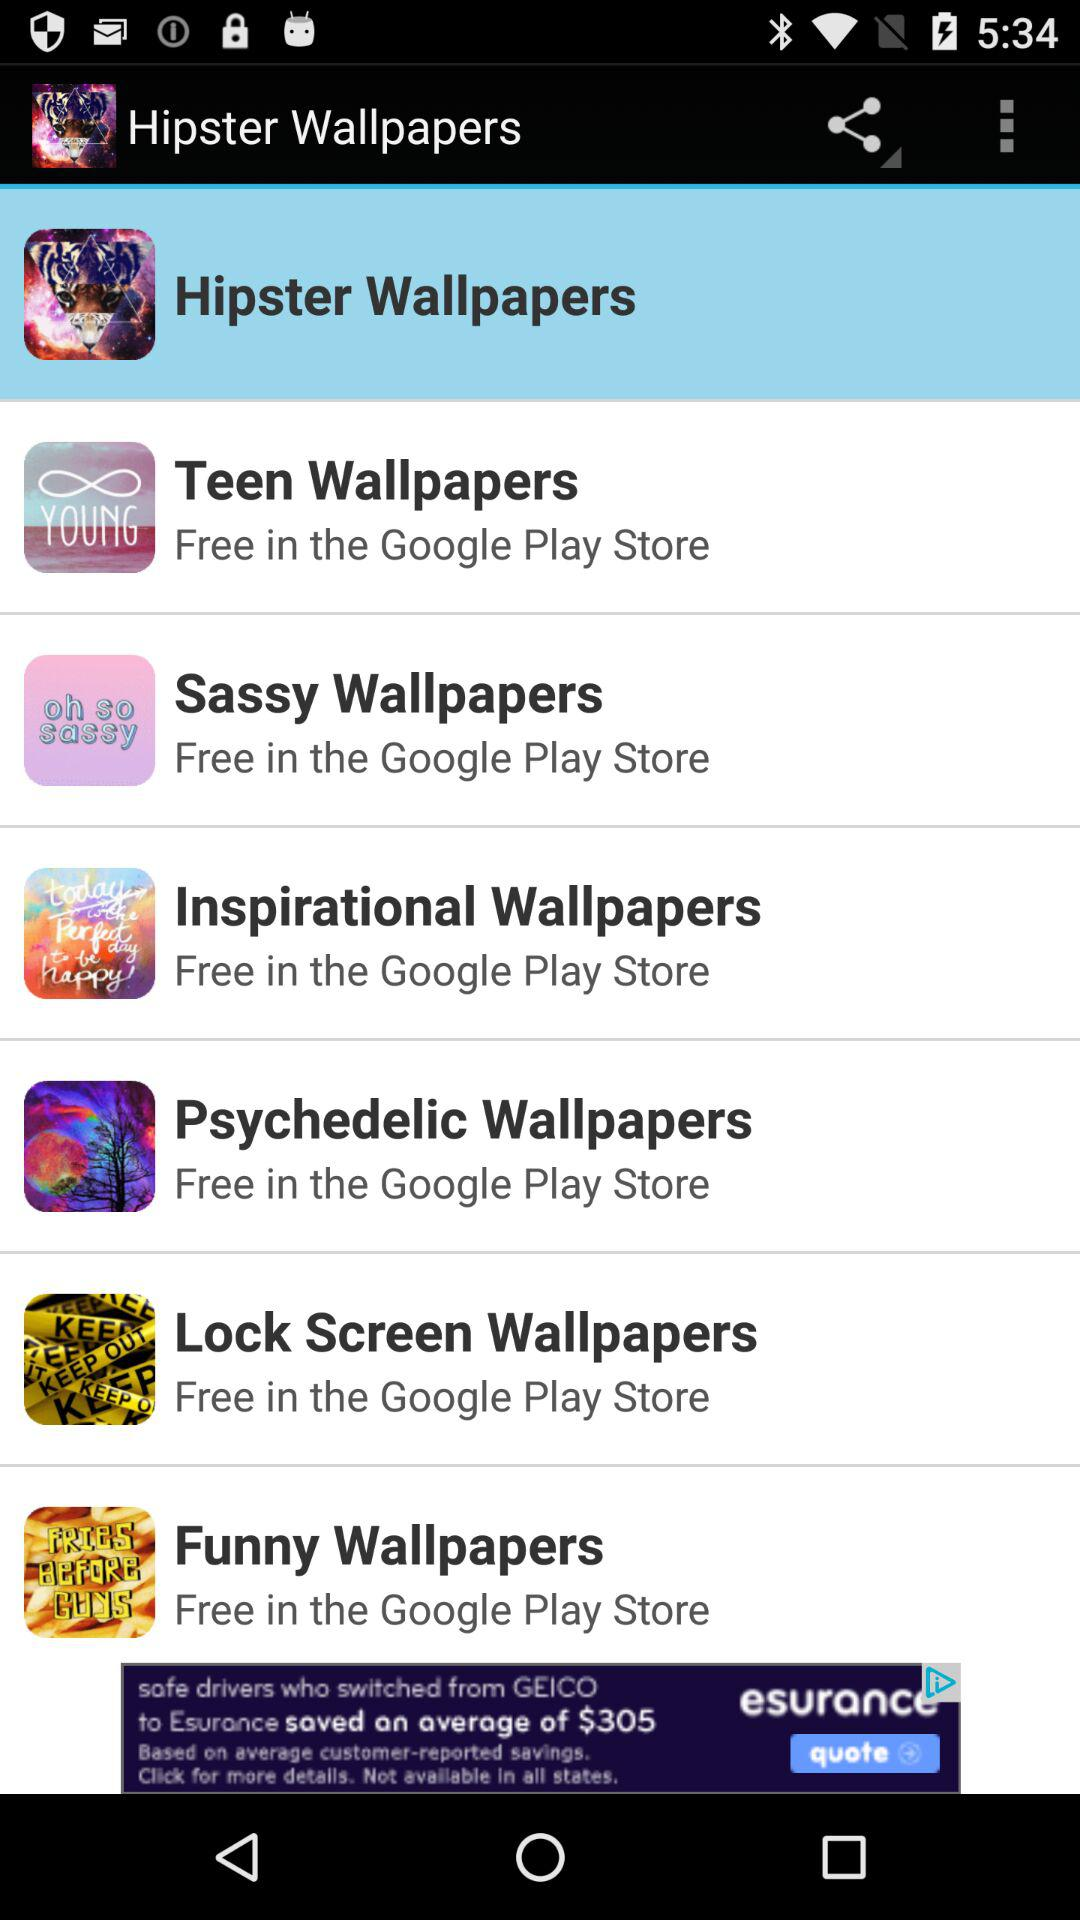Which type of wallpaper is selected? The selected wallpaper is "Hipster Wallpapers". 